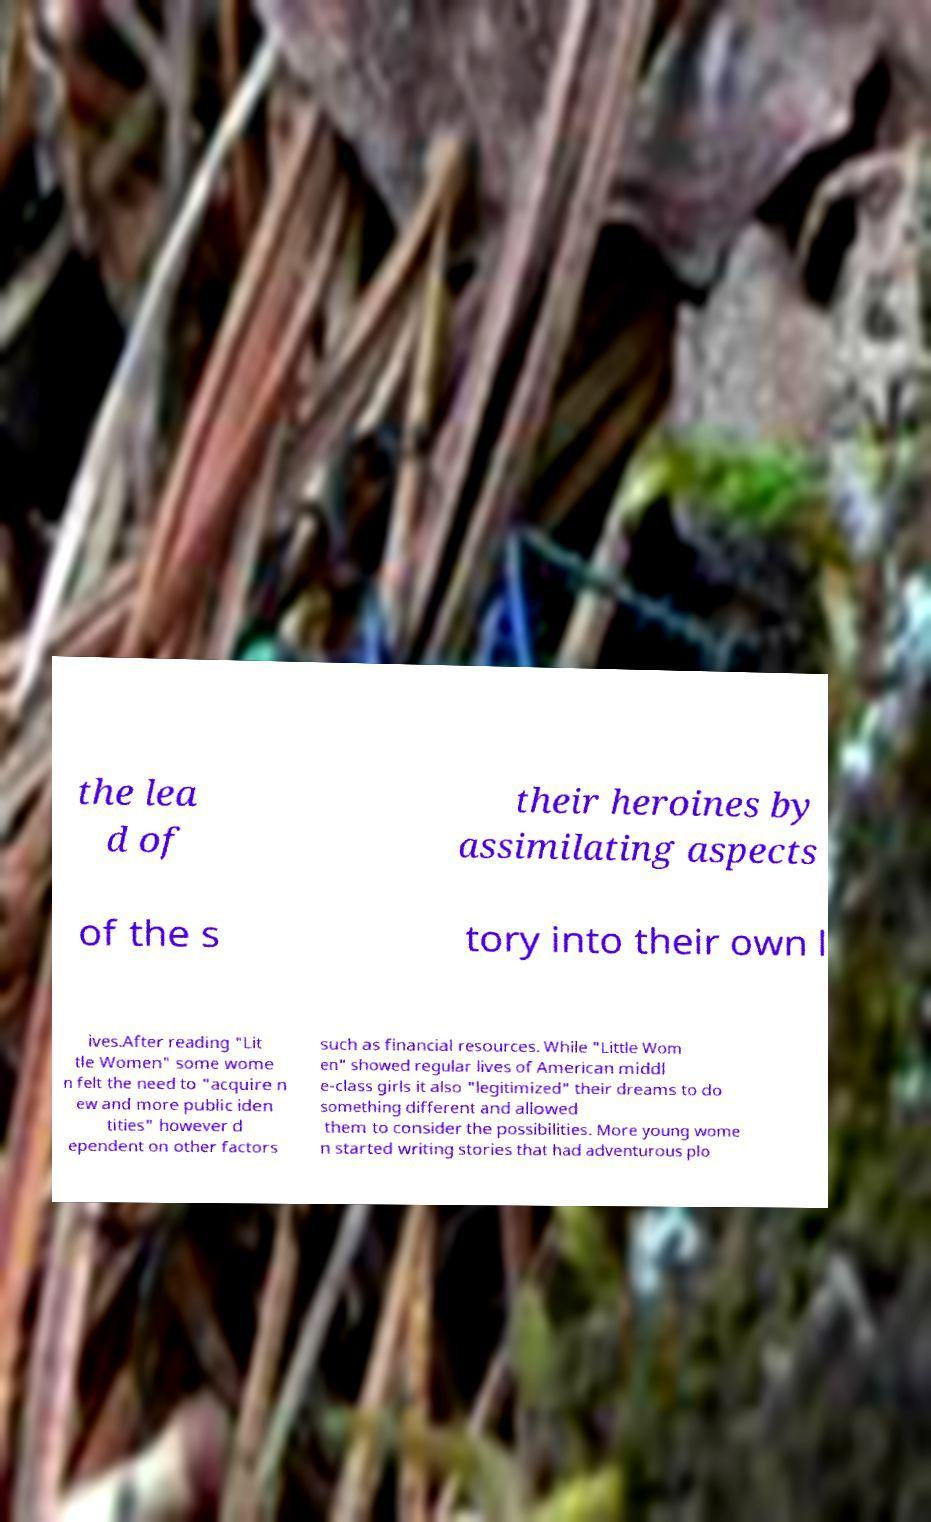Could you extract and type out the text from this image? the lea d of their heroines by assimilating aspects of the s tory into their own l ives.After reading "Lit tle Women" some wome n felt the need to "acquire n ew and more public iden tities" however d ependent on other factors such as financial resources. While "Little Wom en" showed regular lives of American middl e-class girls it also "legitimized" their dreams to do something different and allowed them to consider the possibilities. More young wome n started writing stories that had adventurous plo 